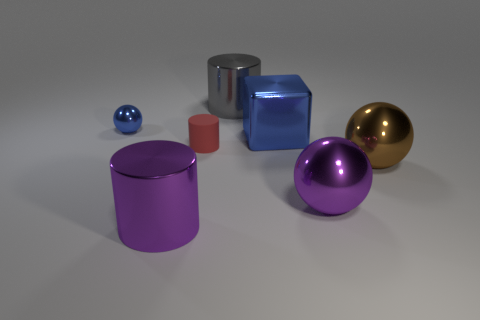Add 1 blocks. How many objects exist? 8 Subtract all cylinders. How many objects are left? 4 Subtract all small gray balls. Subtract all big metallic cylinders. How many objects are left? 5 Add 1 blue spheres. How many blue spheres are left? 2 Add 4 small cyan metallic cubes. How many small cyan metallic cubes exist? 4 Subtract 1 gray cylinders. How many objects are left? 6 